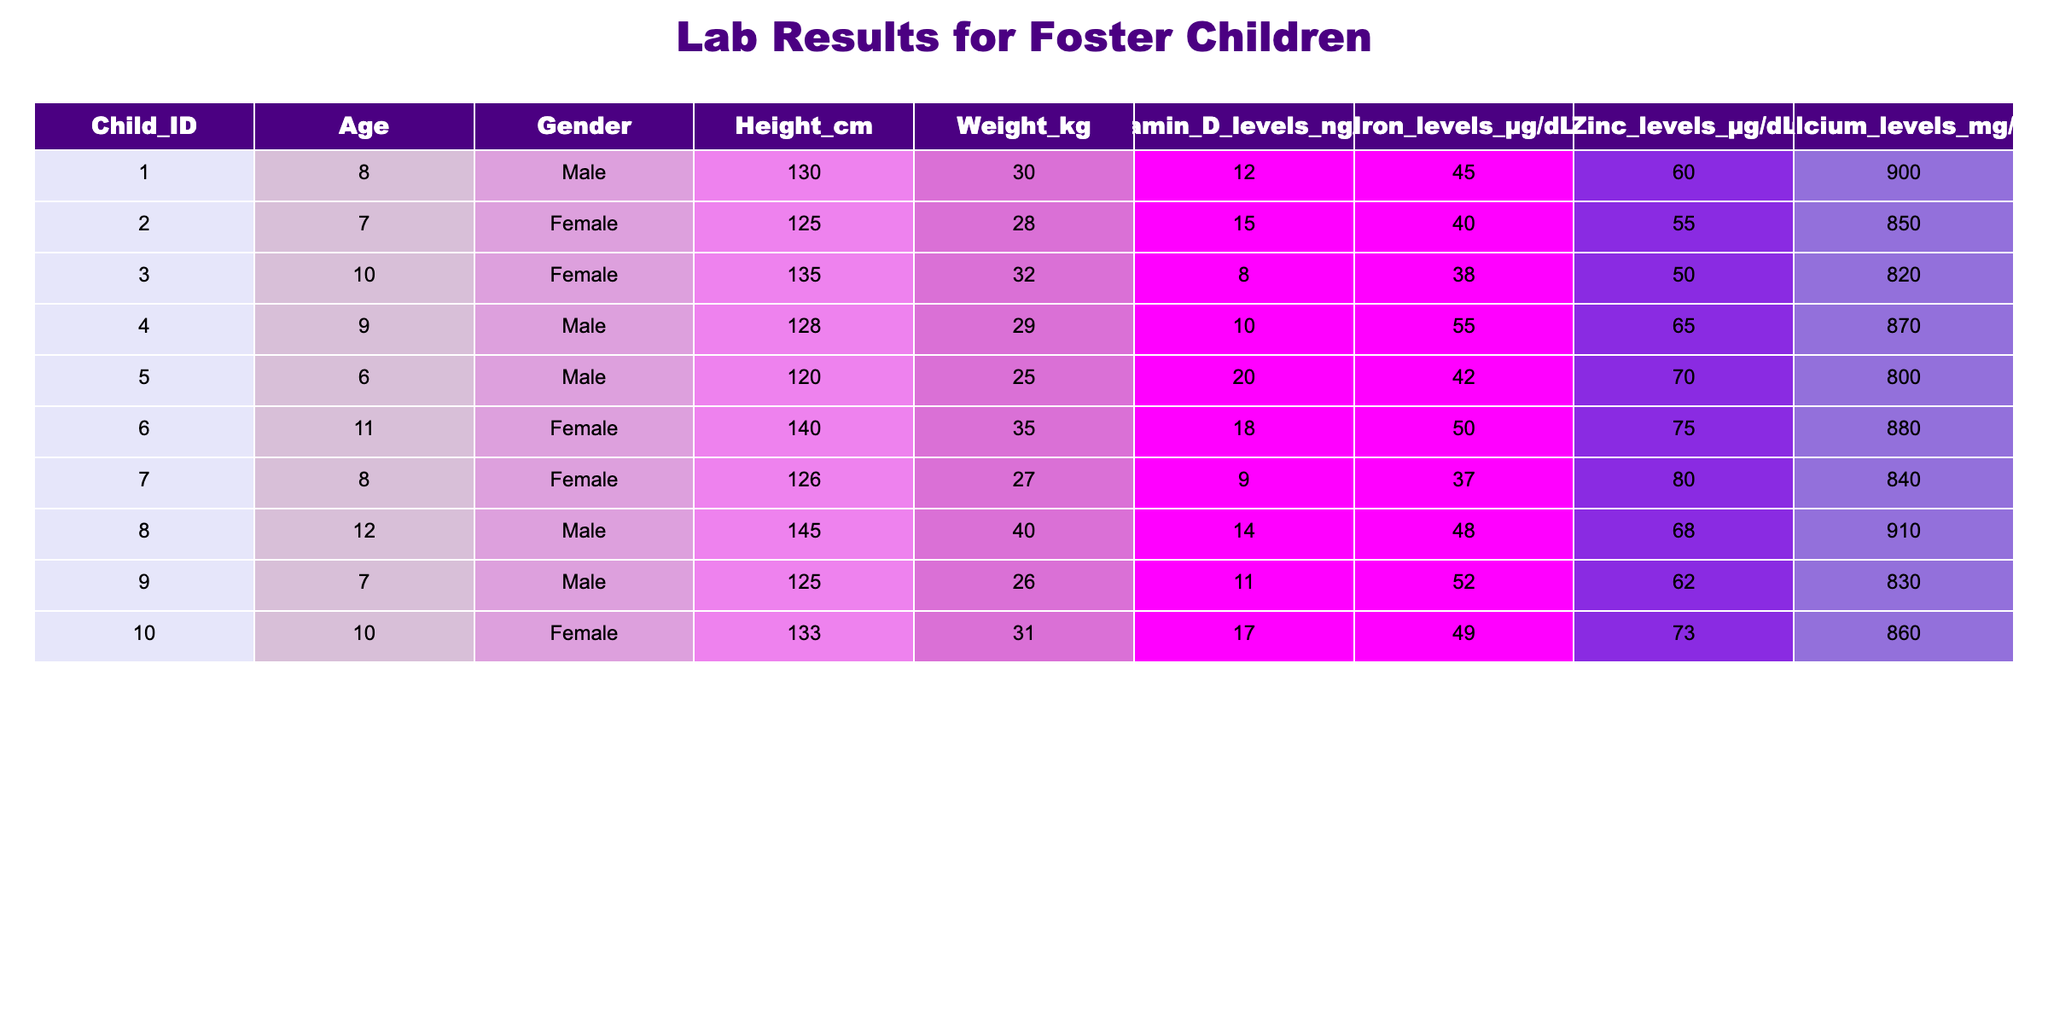What is the Vitamin D level of Child ID 5? Referring to the table, Child ID 5 has a Vitamin D level listed as 20 ng/mL.
Answer: 20 ng/mL Which child has the highest Iron levels? Reviewing the Iron levels column, Child ID 4 has the highest value at 55 µg/dL, which is greater than the Iron levels of all other children.
Answer: Child ID 4 What are the average Zinc levels across all children? To find the average, add the Zinc levels: (60 + 55 + 50 + 65 + 70 + 75 + 80 + 68 + 62 + 73) =  638. There are 10 children, so the average Zinc level is 638/10 = 63.8 µg/dL.
Answer: 63.8 µg/dL Is there a child with Vitamin D levels below 10 ng/mL? Looking through the Vitamin D levels, the minimum is 8 ng/mL from Child ID 3, indicating a child has Vitamin D levels below 10 ng/mL.
Answer: Yes What is the difference in Calcium levels between Child ID 1 and Child ID 3? The Calcium level for Child ID 1 is 900 mg/dL, while for Child ID 3 it is 820 mg/dL. The difference is 900 - 820 = 80 mg/dL.
Answer: 80 mg/dL Which gender has a higher average Iron level? Calculate the average Iron for males (Child IDs 1, 4, 5, 8, 9): (45 + 55 + 42 + 48 + 52) = 242, with an average of 242/5 = 48.4 µg/dL. For females (Child IDs 2, 3, 6, 7, 10): (40 + 38 + 50 + 37 + 49) = 214, with an average of 214/5 = 42.8 µg/dL. The average for males is higher than for females.
Answer: Males What are the total levels of Calcium across all children? Adding all Calcium levels: (900 + 850 + 820 + 870 + 800 + 880 + 840 + 910 + 830 + 860) = 8600 mg/dL.
Answer: 8600 mg/dL Is there a child aged 11 with Zinc levels above 70 µg/dL? Child ID 6 is aged 11 and has Zinc levels of 75 µg/dL, which is above 70 µg/dL.
Answer: Yes What is the median height among the children? To find the median, first list the heights in numerical order: 120, 125, 125, 128, 130, 133, 135, 140, 145. There are 10 values, so the median is the average of the 5th (130 cm) and 6th (133 cm) which is (130 + 133)/2 = 131.5 cm.
Answer: 131.5 cm 